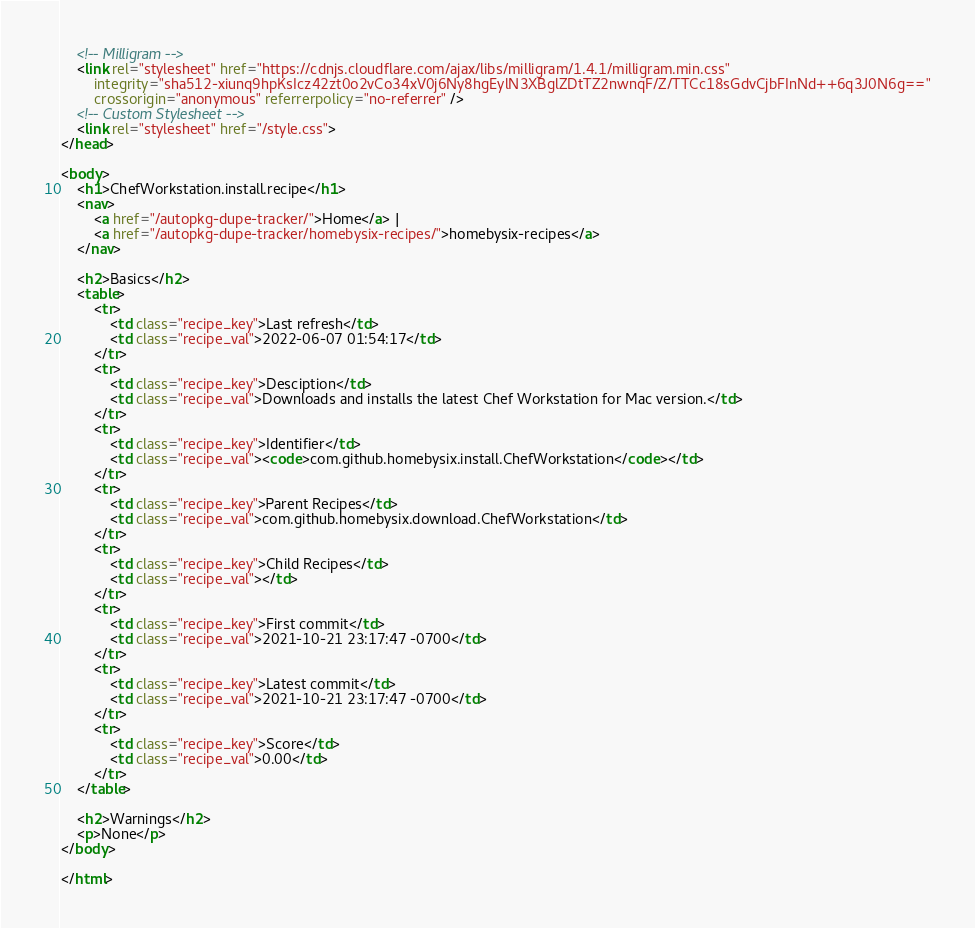Convert code to text. <code><loc_0><loc_0><loc_500><loc_500><_HTML_>    <!-- Milligram -->
    <link rel="stylesheet" href="https://cdnjs.cloudflare.com/ajax/libs/milligram/1.4.1/milligram.min.css"
        integrity="sha512-xiunq9hpKsIcz42zt0o2vCo34xV0j6Ny8hgEylN3XBglZDtTZ2nwnqF/Z/TTCc18sGdvCjbFInNd++6q3J0N6g=="
        crossorigin="anonymous" referrerpolicy="no-referrer" />
    <!-- Custom Stylesheet -->
    <link rel="stylesheet" href="/style.css">
</head>

<body>
    <h1>ChefWorkstation.install.recipe</h1>
    <nav>
        <a href="/autopkg-dupe-tracker/">Home</a> |
        <a href="/autopkg-dupe-tracker/homebysix-recipes/">homebysix-recipes</a>
    </nav>

    <h2>Basics</h2>
    <table>
        <tr>
            <td class="recipe_key">Last refresh</td>
            <td class="recipe_val">2022-06-07 01:54:17</td>
        </tr>
        <tr>
            <td class="recipe_key">Desciption</td>
            <td class="recipe_val">Downloads and installs the latest Chef Workstation for Mac version.</td>
        </tr>
        <tr>
            <td class="recipe_key">Identifier</td>
            <td class="recipe_val"><code>com.github.homebysix.install.ChefWorkstation</code></td>
        </tr>
        <tr>
            <td class="recipe_key">Parent Recipes</td>
            <td class="recipe_val">com.github.homebysix.download.ChefWorkstation</td>
        </tr>
        <tr>
            <td class="recipe_key">Child Recipes</td>
            <td class="recipe_val"></td>
        </tr>
        <tr>
            <td class="recipe_key">First commit</td>
            <td class="recipe_val">2021-10-21 23:17:47 -0700</td>
        </tr>
        <tr>
            <td class="recipe_key">Latest commit</td>
            <td class="recipe_val">2021-10-21 23:17:47 -0700</td>
        </tr>
        <tr>
            <td class="recipe_key">Score</td>
            <td class="recipe_val">0.00</td>
        </tr>
    </table>

    <h2>Warnings</h2>
    <p>None</p>
</body>

</html>
</code> 